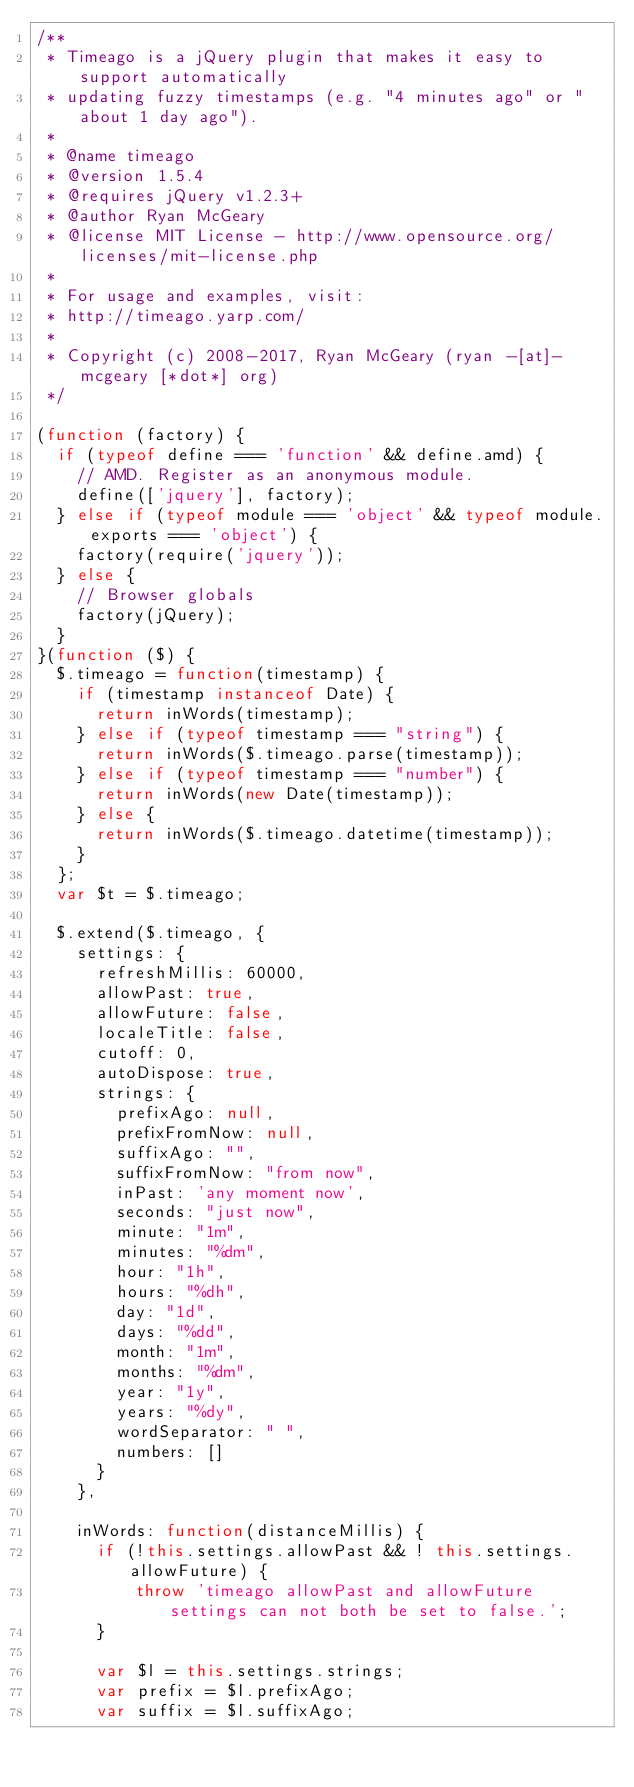Convert code to text. <code><loc_0><loc_0><loc_500><loc_500><_JavaScript_>/**
 * Timeago is a jQuery plugin that makes it easy to support automatically
 * updating fuzzy timestamps (e.g. "4 minutes ago" or "about 1 day ago").
 *
 * @name timeago
 * @version 1.5.4
 * @requires jQuery v1.2.3+
 * @author Ryan McGeary
 * @license MIT License - http://www.opensource.org/licenses/mit-license.php
 *
 * For usage and examples, visit:
 * http://timeago.yarp.com/
 *
 * Copyright (c) 2008-2017, Ryan McGeary (ryan -[at]- mcgeary [*dot*] org)
 */

(function (factory) {
  if (typeof define === 'function' && define.amd) {
    // AMD. Register as an anonymous module.
    define(['jquery'], factory);
  } else if (typeof module === 'object' && typeof module.exports === 'object') {
    factory(require('jquery'));
  } else {
    // Browser globals
    factory(jQuery);
  }
}(function ($) {
  $.timeago = function(timestamp) {
    if (timestamp instanceof Date) {
      return inWords(timestamp);
    } else if (typeof timestamp === "string") {
      return inWords($.timeago.parse(timestamp));
    } else if (typeof timestamp === "number") {
      return inWords(new Date(timestamp));
    } else {
      return inWords($.timeago.datetime(timestamp));
    }
  };
  var $t = $.timeago;

  $.extend($.timeago, {
    settings: {
      refreshMillis: 60000,
      allowPast: true,
      allowFuture: false,
      localeTitle: false,
      cutoff: 0,
      autoDispose: true,
      strings: {
        prefixAgo: null,
        prefixFromNow: null,
        suffixAgo: "",
        suffixFromNow: "from now",
        inPast: 'any moment now',
        seconds: "just now",
        minute: "1m",
        minutes: "%dm",
        hour: "1h",
        hours: "%dh",
        day: "1d",
        days: "%dd",
        month: "1m",
        months: "%dm",
        year: "1y",
        years: "%dy",
        wordSeparator: " ",
        numbers: []
      }
    },

    inWords: function(distanceMillis) {
      if (!this.settings.allowPast && ! this.settings.allowFuture) {
          throw 'timeago allowPast and allowFuture settings can not both be set to false.';
      }

      var $l = this.settings.strings;
      var prefix = $l.prefixAgo;
      var suffix = $l.suffixAgo;</code> 